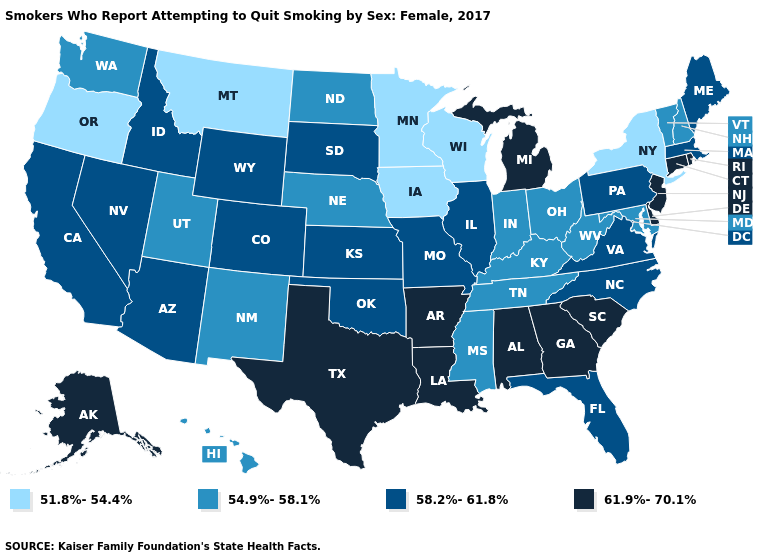What is the highest value in states that border Illinois?
Write a very short answer. 58.2%-61.8%. Does Kansas have the highest value in the USA?
Keep it brief. No. Among the states that border Illinois , does Kentucky have the lowest value?
Concise answer only. No. Does Montana have the lowest value in the West?
Short answer required. Yes. Which states have the lowest value in the Northeast?
Give a very brief answer. New York. What is the lowest value in states that border Mississippi?
Write a very short answer. 54.9%-58.1%. Which states have the highest value in the USA?
Be succinct. Alabama, Alaska, Arkansas, Connecticut, Delaware, Georgia, Louisiana, Michigan, New Jersey, Rhode Island, South Carolina, Texas. Name the states that have a value in the range 51.8%-54.4%?
Keep it brief. Iowa, Minnesota, Montana, New York, Oregon, Wisconsin. What is the lowest value in the West?
Give a very brief answer. 51.8%-54.4%. Name the states that have a value in the range 54.9%-58.1%?
Be succinct. Hawaii, Indiana, Kentucky, Maryland, Mississippi, Nebraska, New Hampshire, New Mexico, North Dakota, Ohio, Tennessee, Utah, Vermont, Washington, West Virginia. What is the lowest value in states that border Wisconsin?
Short answer required. 51.8%-54.4%. Among the states that border Kansas , does Nebraska have the highest value?
Write a very short answer. No. Which states hav the highest value in the South?
Keep it brief. Alabama, Arkansas, Delaware, Georgia, Louisiana, South Carolina, Texas. Does the map have missing data?
Concise answer only. No. Does Oregon have the lowest value in the USA?
Be succinct. Yes. 